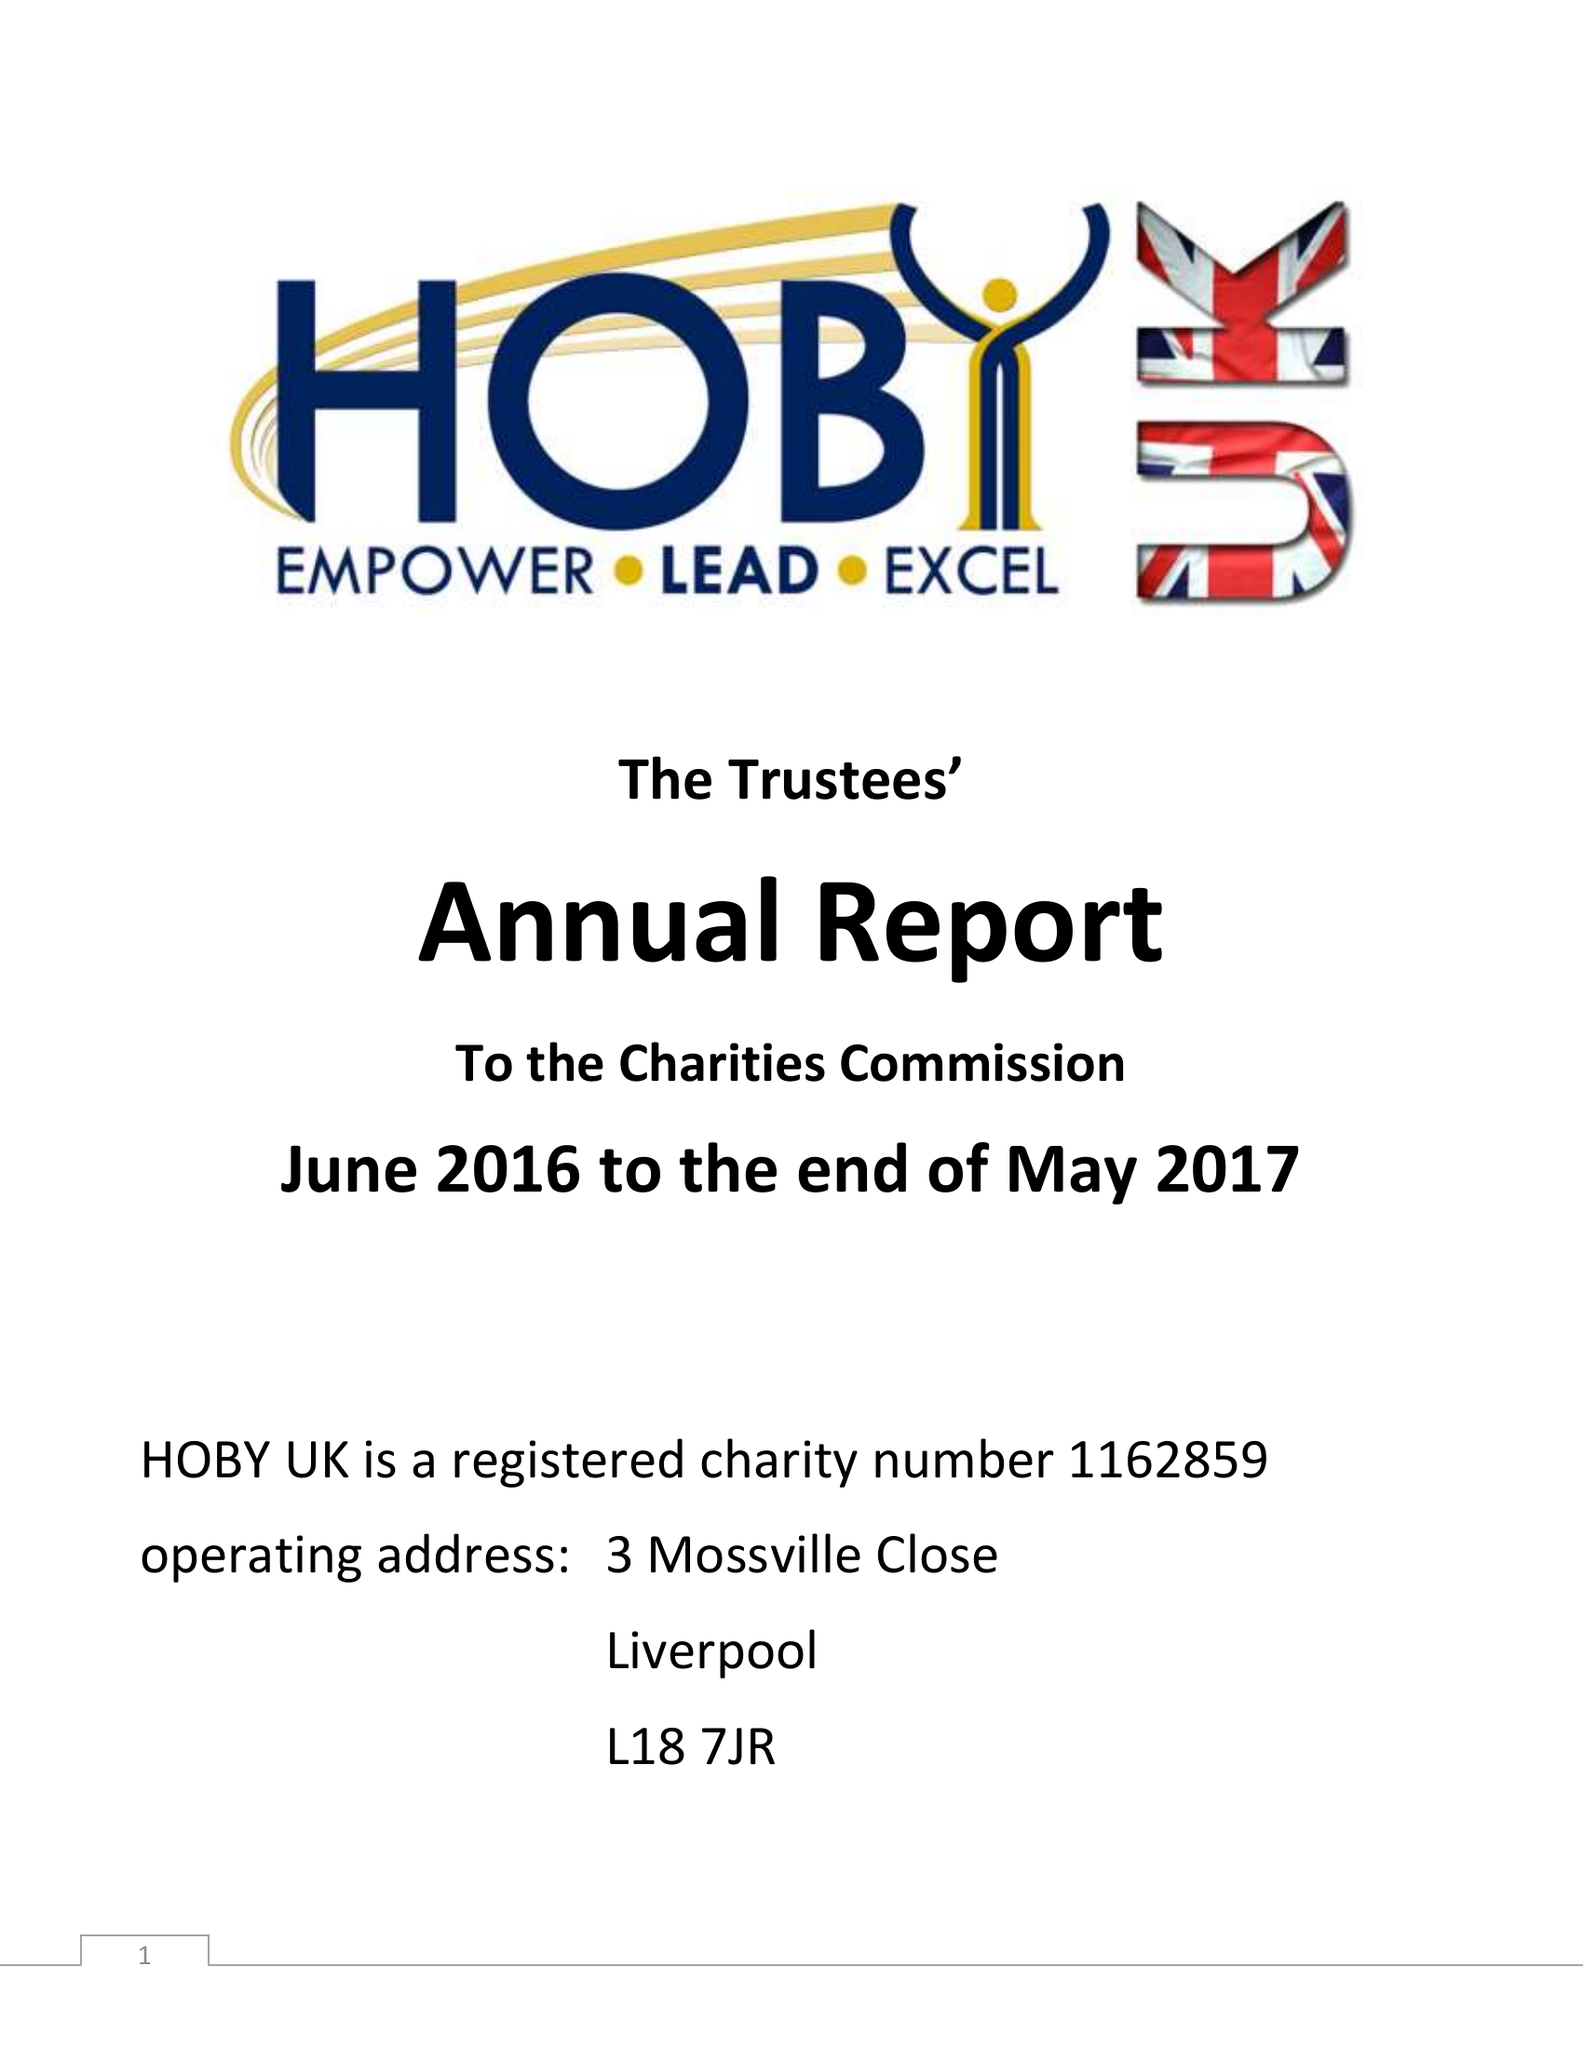What is the value for the address__postcode?
Answer the question using a single word or phrase. L18 7JR 